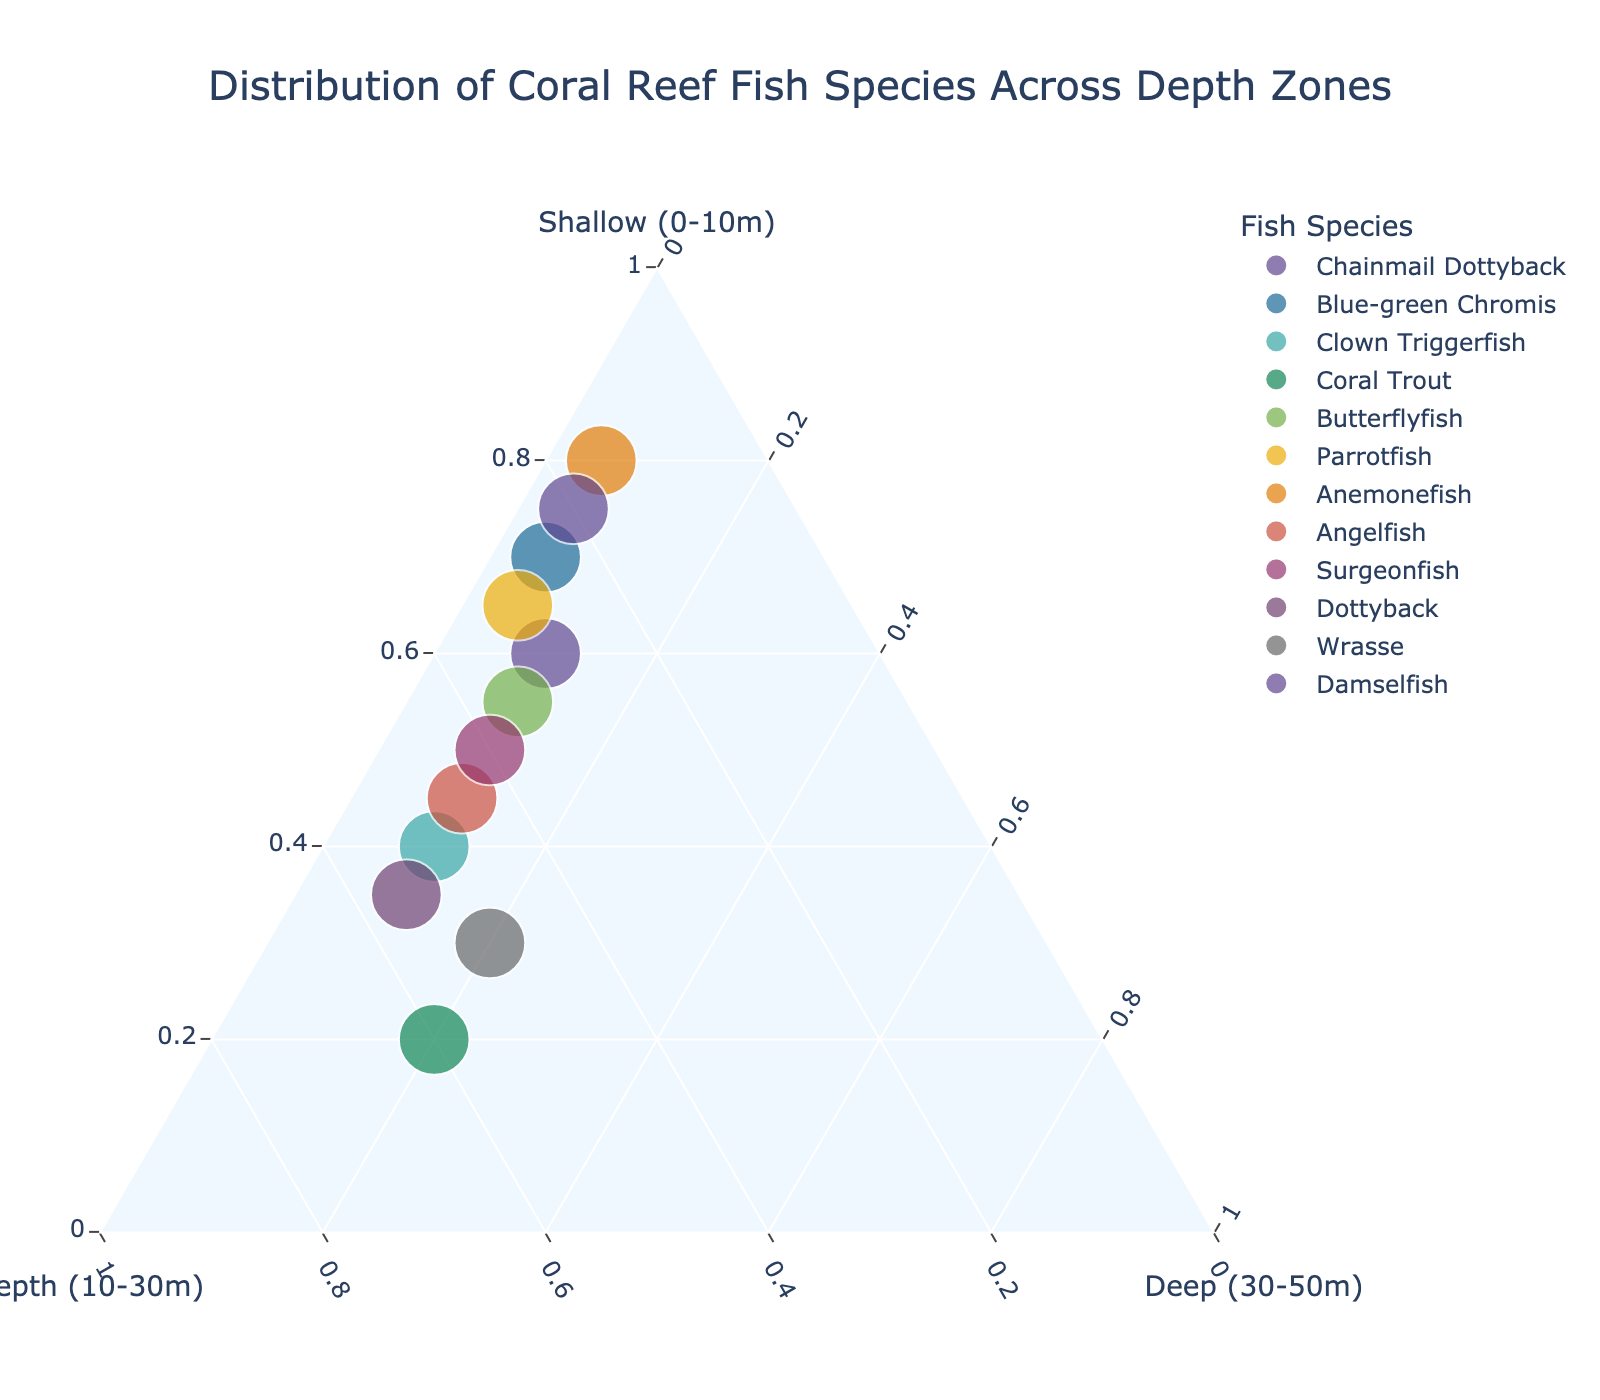What is the title of the plot? The title of the plot is shown at the top of the figure.
Answer: Distribution of Coral Reef Fish Species Across Depth Zones How many different fish species are represented in the plot? Count the number of unique species listed in the plot's legend.
Answer: 12 Which fish species has the highest percentage in the shallow zone (0-10m)? Observe which data point is furthest along the axis labeled 'Shallow (0-10m)'.
Answer: Anemonefish Which two species have the same percentage distribution in the deep zone (30-50m)? Look for points that align vertically along the axis labeled 'Deep (30-50m)' to find species with equal percentages.
Answer: Clown Triggerfish and Butterflyfish What is the percentage distribution of the Chainmail Dottyback in the mid-depth zone (10-30m)? Check the position of the Chainmail Dottyback on the axis labeled 'Mid-depth (10-30m)'.
Answer: 30% Which species shows a more even distribution across all three depth zones? Observe the species that are closer to the center of the ternary plot, indicating a more even distribution.
Answer: Coral Trout Among the Parrotfish and Surgeonfish, which one has a higher percentage in the mid-depth zone (10-30m)? Compare the positions of Parrotfish and Surgeonfish along the 'Mid-depth (10-30m)' axis.
Answer: Surgeonfish What percentage of Damselfish is found in the deep zone (30-50m)? Check the position of the Damselfish data point along the axis labeled 'Deep (30-50m)'.
Answer: 5% Which fish species has the largest total percentage, and how can you tell? Species with the largest total percentage are shown by the size of the data points; the largest circle represents the species with the highest total.
Answer: Anemonefish 